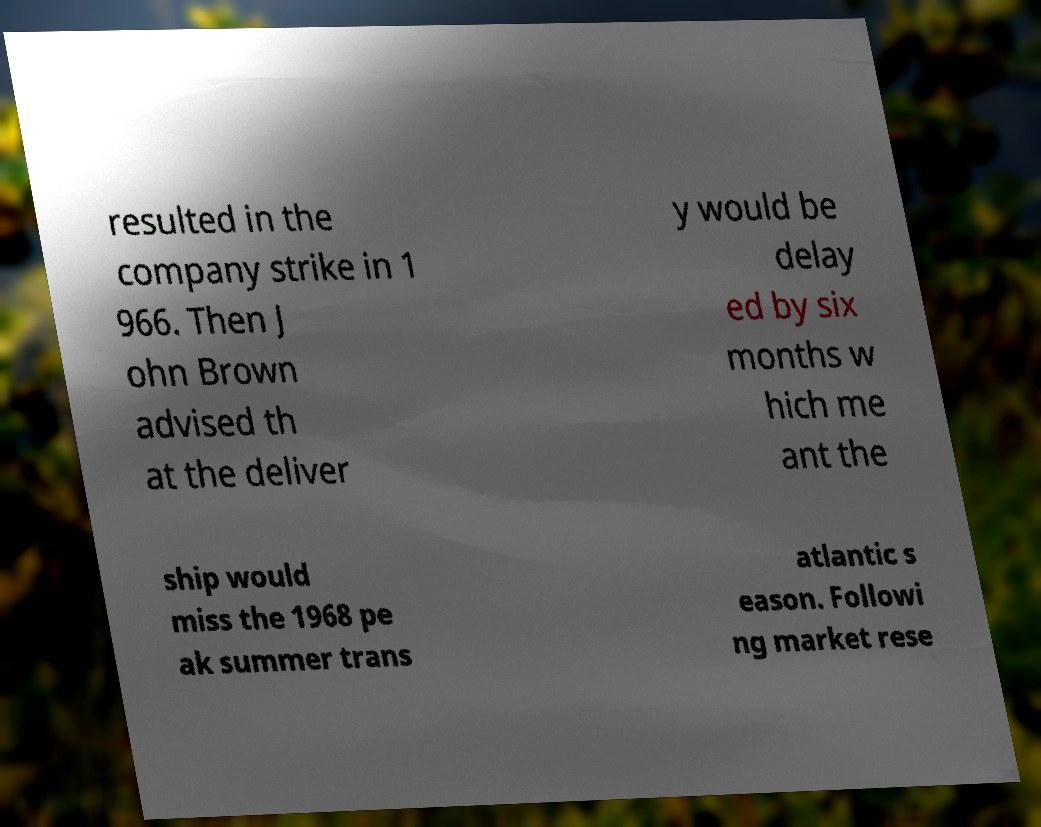Could you extract and type out the text from this image? resulted in the company strike in 1 966. Then J ohn Brown advised th at the deliver y would be delay ed by six months w hich me ant the ship would miss the 1968 pe ak summer trans atlantic s eason. Followi ng market rese 